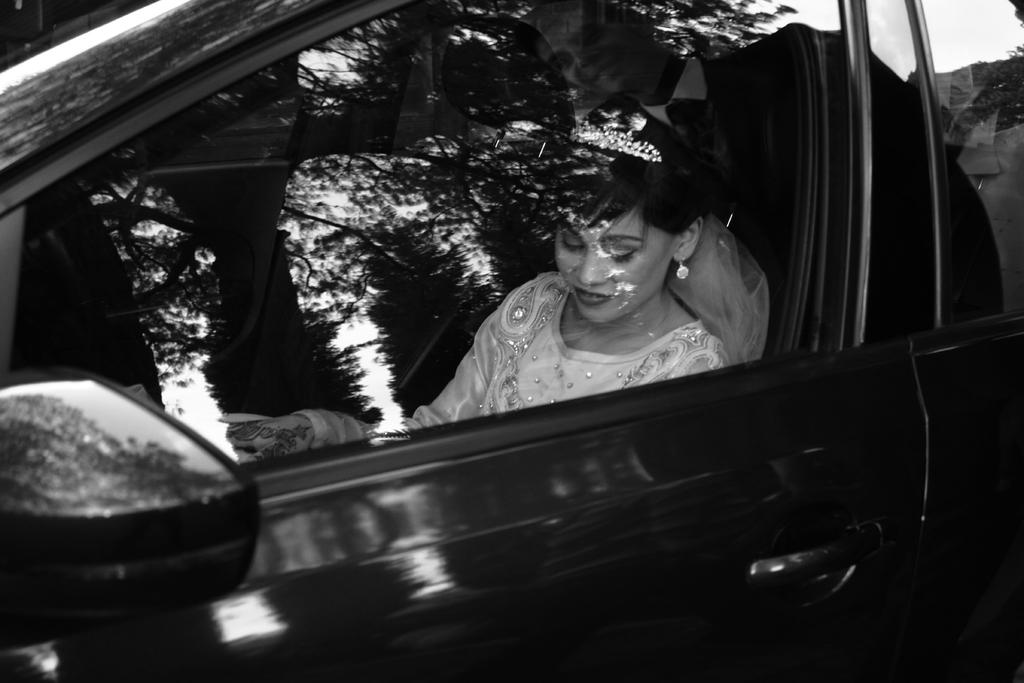Who is present in the image? There is a woman in the image. What is the woman doing in the image? The woman is sitting in a car. What can be said about the car's color? The car is black in color. What type of vase can be seen in the image? There is no vase present in the image. What subject is the woman teaching in the image? The image does not depict the woman teaching any subject. 